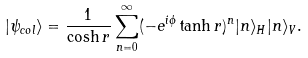Convert formula to latex. <formula><loc_0><loc_0><loc_500><loc_500>| \psi _ { c o l } \rangle = \frac { 1 } { \cosh r } \sum _ { n = 0 } ^ { \infty } ( - e ^ { i \phi } \tanh r ) ^ { n } | n \rangle _ { H } | n \rangle _ { V } .</formula> 